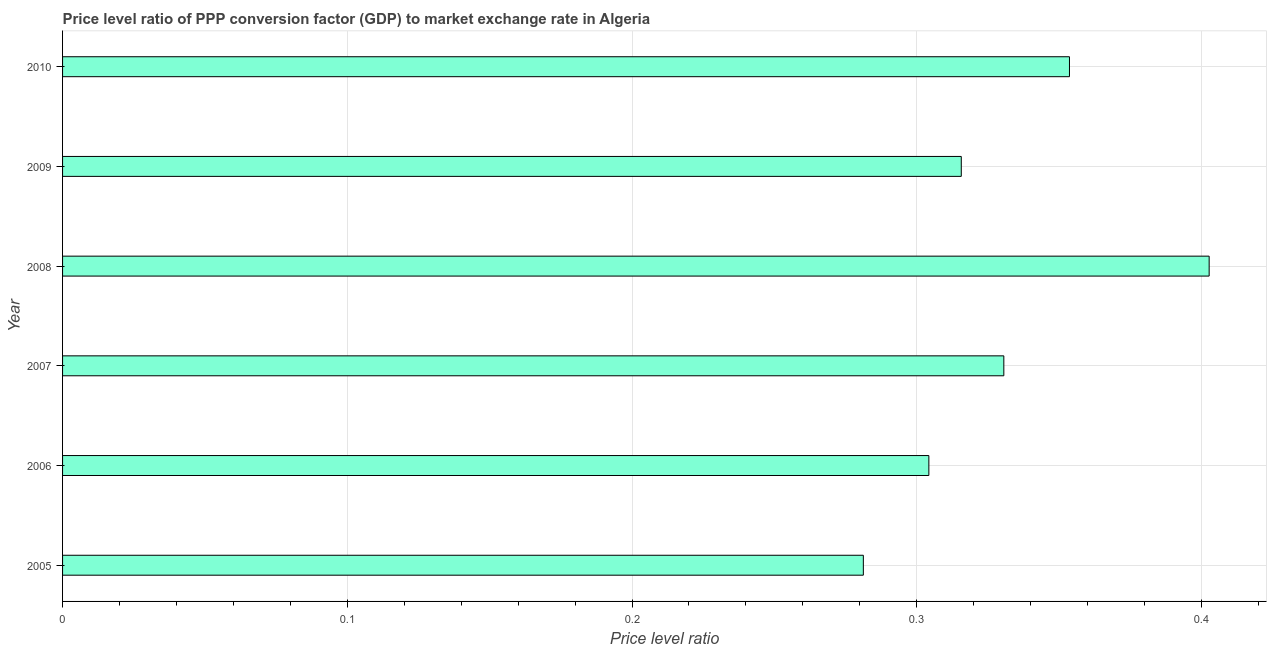Does the graph contain any zero values?
Your response must be concise. No. Does the graph contain grids?
Offer a terse response. Yes. What is the title of the graph?
Provide a succinct answer. Price level ratio of PPP conversion factor (GDP) to market exchange rate in Algeria. What is the label or title of the X-axis?
Your response must be concise. Price level ratio. What is the price level ratio in 2007?
Offer a very short reply. 0.33. Across all years, what is the maximum price level ratio?
Keep it short and to the point. 0.4. Across all years, what is the minimum price level ratio?
Provide a succinct answer. 0.28. In which year was the price level ratio minimum?
Provide a short and direct response. 2005. What is the sum of the price level ratio?
Your answer should be very brief. 1.99. What is the difference between the price level ratio in 2006 and 2008?
Provide a succinct answer. -0.1. What is the average price level ratio per year?
Your response must be concise. 0.33. What is the median price level ratio?
Your answer should be compact. 0.32. Do a majority of the years between 2008 and 2005 (inclusive) have price level ratio greater than 0.34 ?
Ensure brevity in your answer.  Yes. What is the ratio of the price level ratio in 2008 to that in 2010?
Your response must be concise. 1.14. Is the price level ratio in 2008 less than that in 2009?
Provide a succinct answer. No. What is the difference between the highest and the second highest price level ratio?
Give a very brief answer. 0.05. What is the difference between the highest and the lowest price level ratio?
Provide a short and direct response. 0.12. In how many years, is the price level ratio greater than the average price level ratio taken over all years?
Ensure brevity in your answer.  2. Are all the bars in the graph horizontal?
Ensure brevity in your answer.  Yes. What is the Price level ratio in 2005?
Provide a short and direct response. 0.28. What is the Price level ratio of 2006?
Keep it short and to the point. 0.3. What is the Price level ratio of 2007?
Keep it short and to the point. 0.33. What is the Price level ratio of 2008?
Make the answer very short. 0.4. What is the Price level ratio of 2009?
Provide a succinct answer. 0.32. What is the Price level ratio of 2010?
Ensure brevity in your answer.  0.35. What is the difference between the Price level ratio in 2005 and 2006?
Ensure brevity in your answer.  -0.02. What is the difference between the Price level ratio in 2005 and 2007?
Provide a succinct answer. -0.05. What is the difference between the Price level ratio in 2005 and 2008?
Offer a very short reply. -0.12. What is the difference between the Price level ratio in 2005 and 2009?
Your response must be concise. -0.03. What is the difference between the Price level ratio in 2005 and 2010?
Make the answer very short. -0.07. What is the difference between the Price level ratio in 2006 and 2007?
Give a very brief answer. -0.03. What is the difference between the Price level ratio in 2006 and 2008?
Give a very brief answer. -0.1. What is the difference between the Price level ratio in 2006 and 2009?
Keep it short and to the point. -0.01. What is the difference between the Price level ratio in 2006 and 2010?
Ensure brevity in your answer.  -0.05. What is the difference between the Price level ratio in 2007 and 2008?
Provide a short and direct response. -0.07. What is the difference between the Price level ratio in 2007 and 2009?
Your response must be concise. 0.01. What is the difference between the Price level ratio in 2007 and 2010?
Give a very brief answer. -0.02. What is the difference between the Price level ratio in 2008 and 2009?
Provide a short and direct response. 0.09. What is the difference between the Price level ratio in 2008 and 2010?
Make the answer very short. 0.05. What is the difference between the Price level ratio in 2009 and 2010?
Offer a very short reply. -0.04. What is the ratio of the Price level ratio in 2005 to that in 2006?
Make the answer very short. 0.92. What is the ratio of the Price level ratio in 2005 to that in 2007?
Your answer should be compact. 0.85. What is the ratio of the Price level ratio in 2005 to that in 2008?
Offer a very short reply. 0.7. What is the ratio of the Price level ratio in 2005 to that in 2009?
Give a very brief answer. 0.89. What is the ratio of the Price level ratio in 2005 to that in 2010?
Your response must be concise. 0.8. What is the ratio of the Price level ratio in 2006 to that in 2008?
Provide a succinct answer. 0.76. What is the ratio of the Price level ratio in 2006 to that in 2010?
Ensure brevity in your answer.  0.86. What is the ratio of the Price level ratio in 2007 to that in 2008?
Ensure brevity in your answer.  0.82. What is the ratio of the Price level ratio in 2007 to that in 2009?
Provide a succinct answer. 1.05. What is the ratio of the Price level ratio in 2007 to that in 2010?
Keep it short and to the point. 0.94. What is the ratio of the Price level ratio in 2008 to that in 2009?
Keep it short and to the point. 1.28. What is the ratio of the Price level ratio in 2008 to that in 2010?
Your response must be concise. 1.14. What is the ratio of the Price level ratio in 2009 to that in 2010?
Your response must be concise. 0.89. 